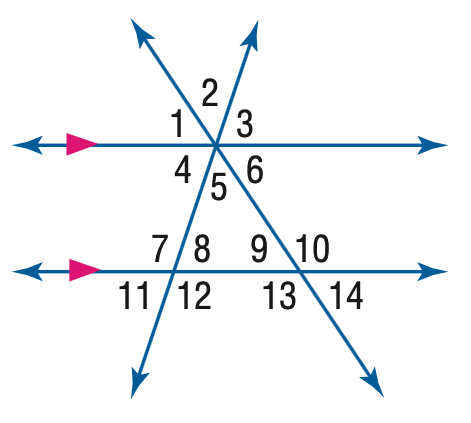Answer the mathemtical geometry problem and directly provide the correct option letter.
Question: In the figure, m \angle 11 = 62 and m \angle 14 = 38. Find the measure of \angle 4.
Choices: A: 38 B: 62 C: 118 D: 142 B 